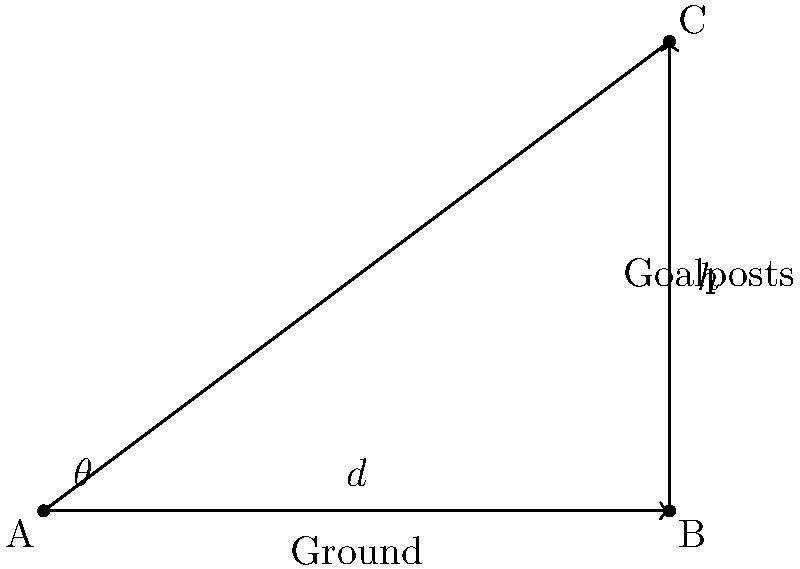In rugby, a conversion kick is attempted after a try is scored. The kicker aims to kick the ball over the crossbar of the goalposts. Given that the distance from the kicker to the goalposts (d) is 30 meters and the height of the crossbar (h) is 3 meters, what is the optimal angle (θ) for the kick to just clear the crossbar? Let's approach this step-by-step:

1) The scenario forms a right triangle, where:
   - The ground distance (d) is the base of the triangle
   - The height of the crossbar (h) is the height of the triangle
   - The angle we're looking for (θ) is the angle between the ground and the path of the ball

2) In a right triangle, the tangent of an angle is the ratio of the opposite side to the adjacent side:

   $$\tan(\theta) = \frac{\text{opposite}}{\text{adjacent}} = \frac{h}{d}$$

3) We're given that:
   h = 3 meters
   d = 30 meters

4) Substituting these values:

   $$\tan(\theta) = \frac{3}{30} = \frac{1}{10} = 0.1$$

5) To find θ, we need to take the inverse tangent (arctangent) of this ratio:

   $$\theta = \arctan(0.1)$$

6) Using a calculator or computer:

   $$\theta \approx 5.71 \text{ degrees}$$

This angle would make the ball just clear the crossbar. However, in a real game, the kicker would aim for a slightly higher angle to account for factors like wind and to ensure the ball clears the crossbar comfortably.
Answer: $5.71^\circ$ 